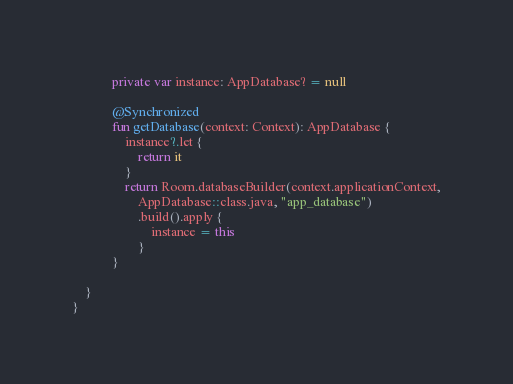<code> <loc_0><loc_0><loc_500><loc_500><_Kotlin_>            private var instance: AppDatabase? = null

            @Synchronized
            fun getDatabase(context: Context): AppDatabase {
                instance?.let {
                    return it
                }
                return Room.databaseBuilder(context.applicationContext,
                    AppDatabase::class.java, "app_database")
                    .build().apply {
                        instance = this
                    }
            }

    }
}</code> 